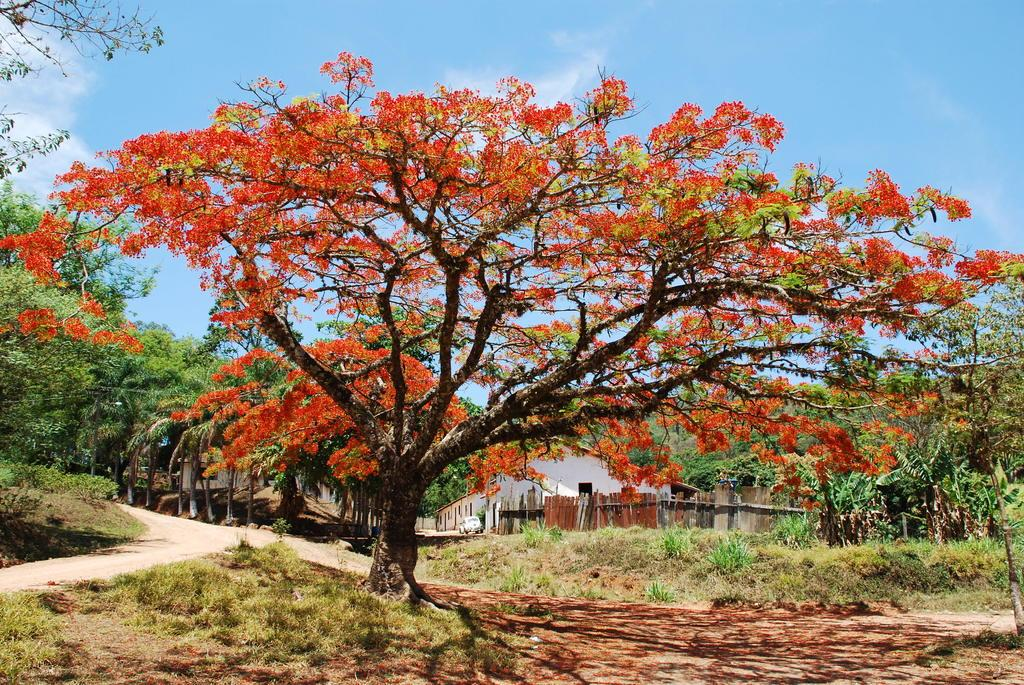What type of flowers can be seen in the image? There are flowers in red color in the image. What can be seen in the background of the image? There are trees in green color in the background of the image. What is the color of the building in the image? The building in the image is in white color. What colors are visible in the sky in the image? The sky is in blue and white color. Can you tell me how many ants are crawling on the flowers in the image? There are no ants present in the image; it only features flowers, trees, a building, and the sky. What type of stew is being served in the image? There is no stew present in the image; it does not depict any food items. 